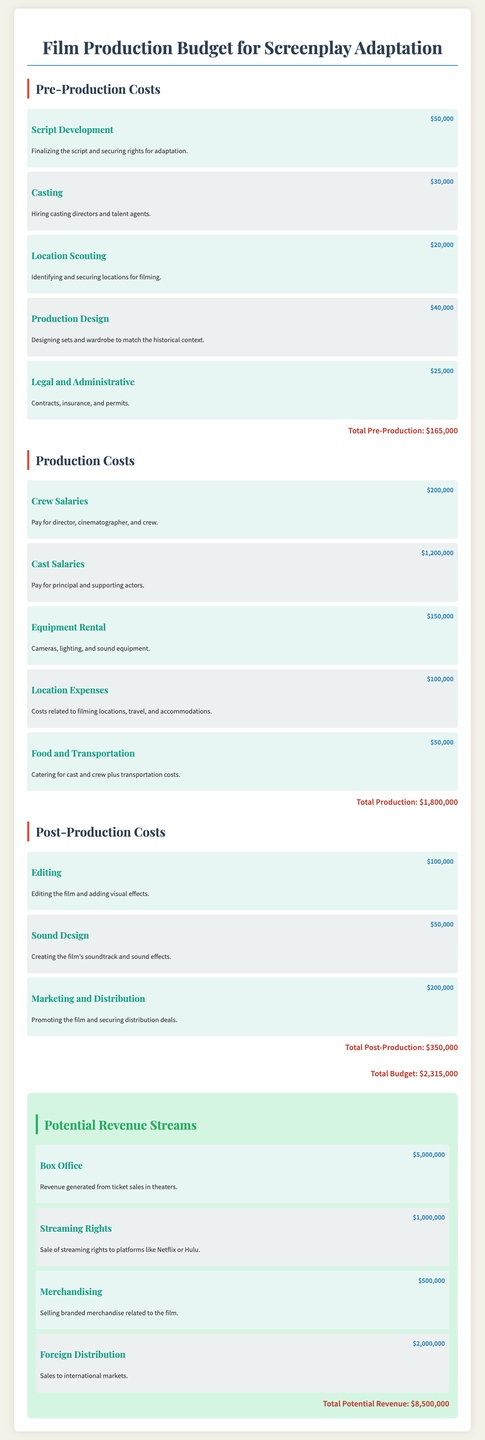What are the total pre-production costs? The total pre-production costs are listed at the end of that section, which is the sum of all individual pre-production items.
Answer: $165,000 What is the budget for crew salaries during production? The budget for crew salaries is specified alongside crew-related expenses, which is the second item in the production costs list.
Answer: $200,000 How much are the estimated earnings from box office sales? The estimated earnings from box office sales is provided in the revenue streams section, which details the expected financial outcome from ticket sales.
Answer: $5,000,000 What is the total production cost? The total production cost is summarized at the end of the production section, reflecting the overall expenditure for that phase.
Answer: $1,800,000 How much is budgeted for marketing and distribution in post-production? The amount allocated for marketing and distribution is found in the post-production section, specifically noted as a separate item.
Answer: $200,000 What is the total estimated revenue from all sources? The total estimated revenue is calculated by summing the potential revenue streams listed in the document, noted at the end of that section.
Answer: $8,500,000 What item in pre-production has the highest cost? The item with the highest cost in pre-production is indicated among the different expenses listed, focusing on the individual amounts for comparison.
Answer: Script Development Which section of the document includes legal and administrative costs? The section that includes legal and administrative costs is identified clearly as part of the pre-production segment in the budget breakdown.
Answer: Pre-Production Costs What is the cost associated with sound design in post-production? The cost linked to sound design is explicitly stated as a separate item within the post-production costing details.
Answer: $50,000 